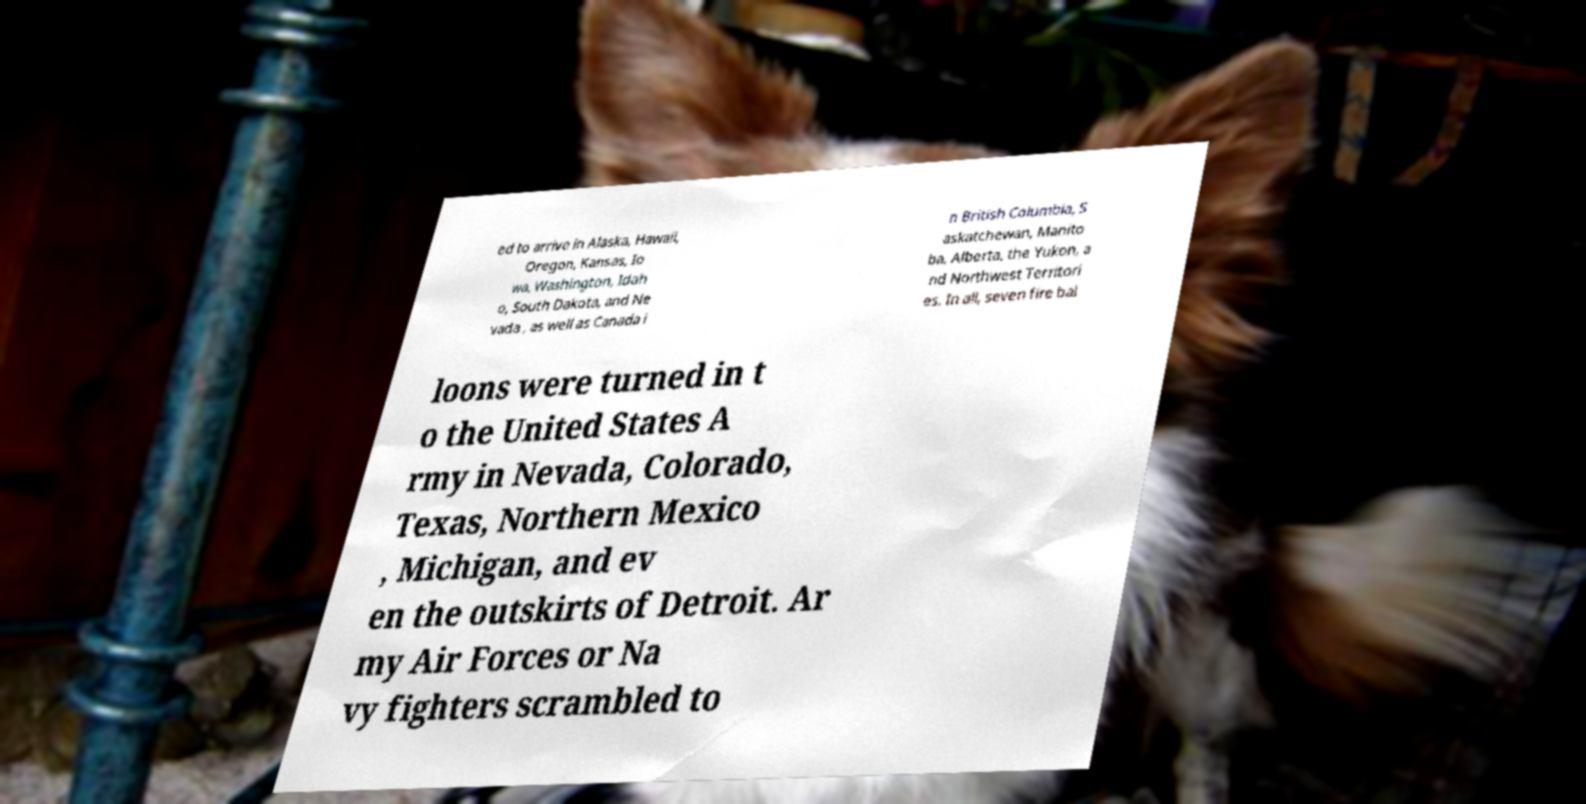Please identify and transcribe the text found in this image. ed to arrive in Alaska, Hawaii, Oregon, Kansas, Io wa, Washington, Idah o, South Dakota, and Ne vada , as well as Canada i n British Columbia, S askatchewan, Manito ba, Alberta, the Yukon, a nd Northwest Territori es. In all, seven fire bal loons were turned in t o the United States A rmy in Nevada, Colorado, Texas, Northern Mexico , Michigan, and ev en the outskirts of Detroit. Ar my Air Forces or Na vy fighters scrambled to 